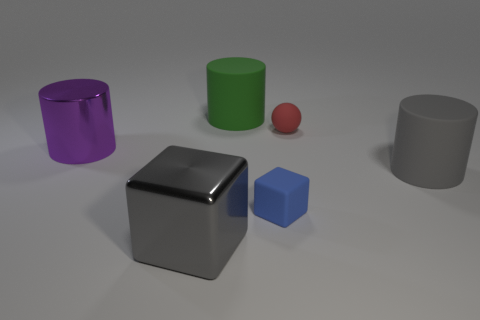How many small blue objects are made of the same material as the large purple cylinder?
Provide a short and direct response. 0. There is a metallic object that is behind the gray rubber cylinder; does it have the same size as the block behind the shiny cube?
Keep it short and to the point. No. There is a gray object in front of the large cylinder on the right side of the large green rubber object; what is its material?
Give a very brief answer. Metal. Are there fewer tiny red balls behind the small red object than large metallic cylinders that are on the right side of the large shiny cylinder?
Make the answer very short. No. There is a cylinder that is the same color as the big block; what material is it?
Make the answer very short. Rubber. Is there any other thing that has the same shape as the small blue thing?
Offer a terse response. Yes. There is a large object that is behind the big purple object; what is its material?
Make the answer very short. Rubber. Is there anything else that has the same size as the red rubber thing?
Ensure brevity in your answer.  Yes. Are there any large rubber cylinders right of the tiny blue thing?
Provide a succinct answer. Yes. There is a small red rubber object; what shape is it?
Offer a very short reply. Sphere. 